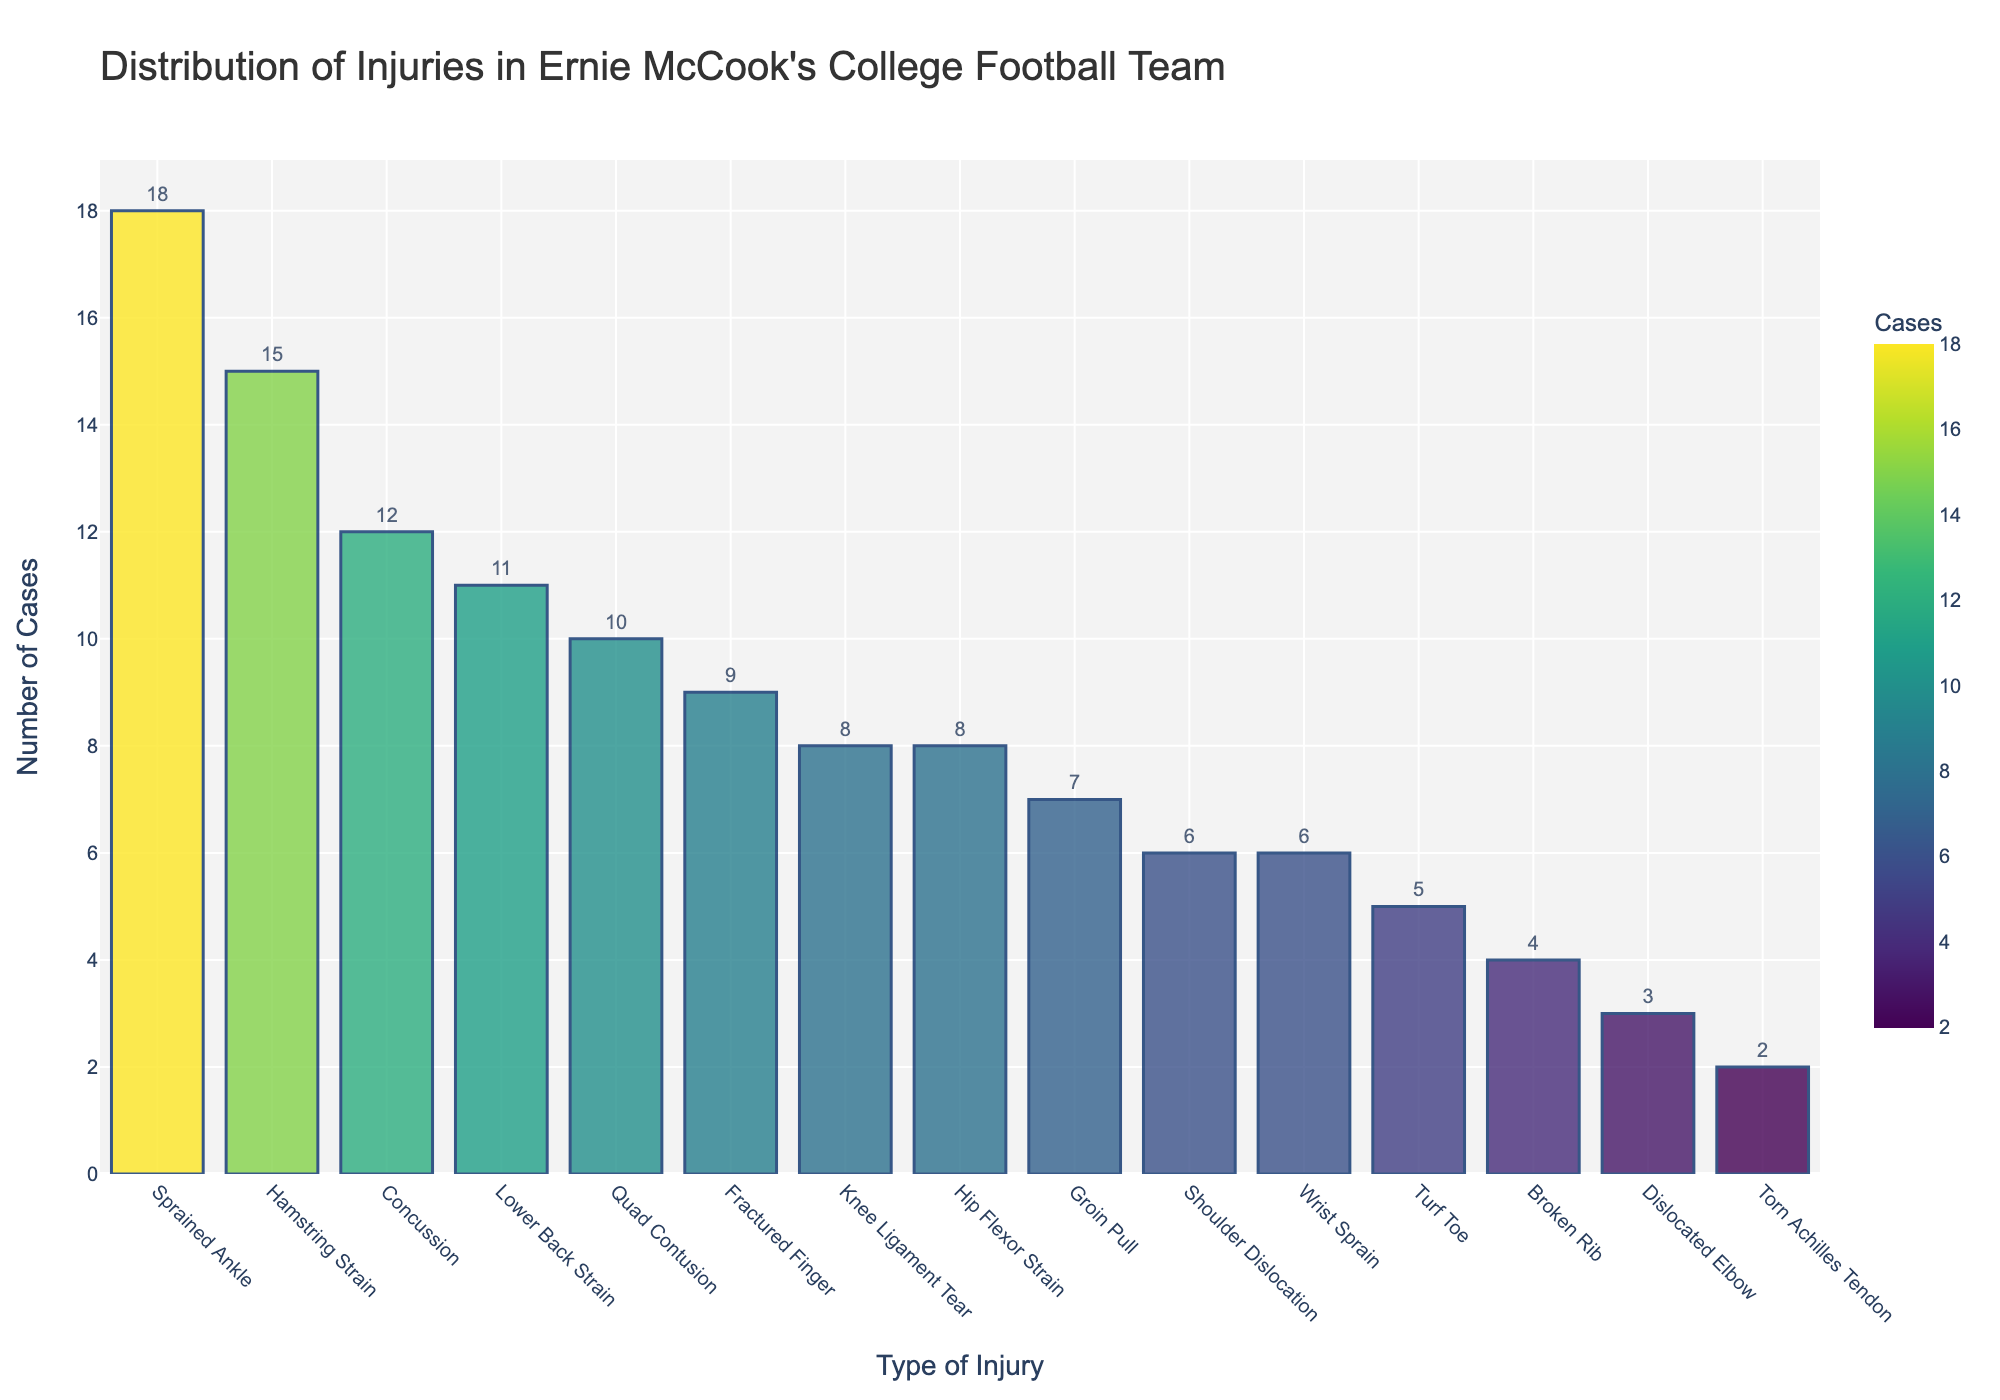Which injury type had the highest number of cases? Look at the bar with the highest value, which represents the highest number of cases.
Answer: Sprained Ankle Which injury types had fewer cases than Lower Back Strain? Identify the number of cases for Lower Back Strain (11) and compare it to other injuries with fewer cases.
Answer: Concussion, Knee Ligament Tear, Shoulder Dislocation, Fractured Finger, Turf Toe, Groin Pull, Dislocated Elbow, Broken Rib, Torn Achilles Tendon, Wrist Sprain, Hip Flexor Strain What is the total number of cases for the three most common injuries? Sum the number of cases for the top three injuries: Sprained Ankle (18), Hamstring Strain (15), Concussion (12).
Answer: 45 Which injury type had the lowest number of cases? Look at the bar with the lowest value, which represents the lowest number of cases.
Answer: Torn Achilles Tendon How many more cases were there of Sprained Ankle than Knee Ligament Tear? Subtract the number of cases for Knee Ligament Tear (8) from Sprained Ankle (18).
Answer: 10 How many injuries had more than 10 cases? Count the injury types where the number of cases is greater than 10.
Answer: 4 Which types of injuries resulted in a number of cases very close to 10? Identify injuries with case numbers 10 or close to 10: Quad Contusion (10), Lower Back Strain (11), Fractured Finger (9), and Groin Pull (7).
Answer: Quad Contusion, Lower Back Strain, Fractured Finger, Groin Pull What is the total number of all injury cases combined? Sum of the number of cases for all injury types.
Answer: 124 What is the average number of cases per injury type? Divide the total number of cases (124) by the number of injury types (15).
Answer: 8.27 Which injury type is closest in number of cases to Concussion? Compare the number of cases for Concussion (12) with other injury types to find the closest number, which is Lower Back Strain (11).
Answer: Lower Back Strain 